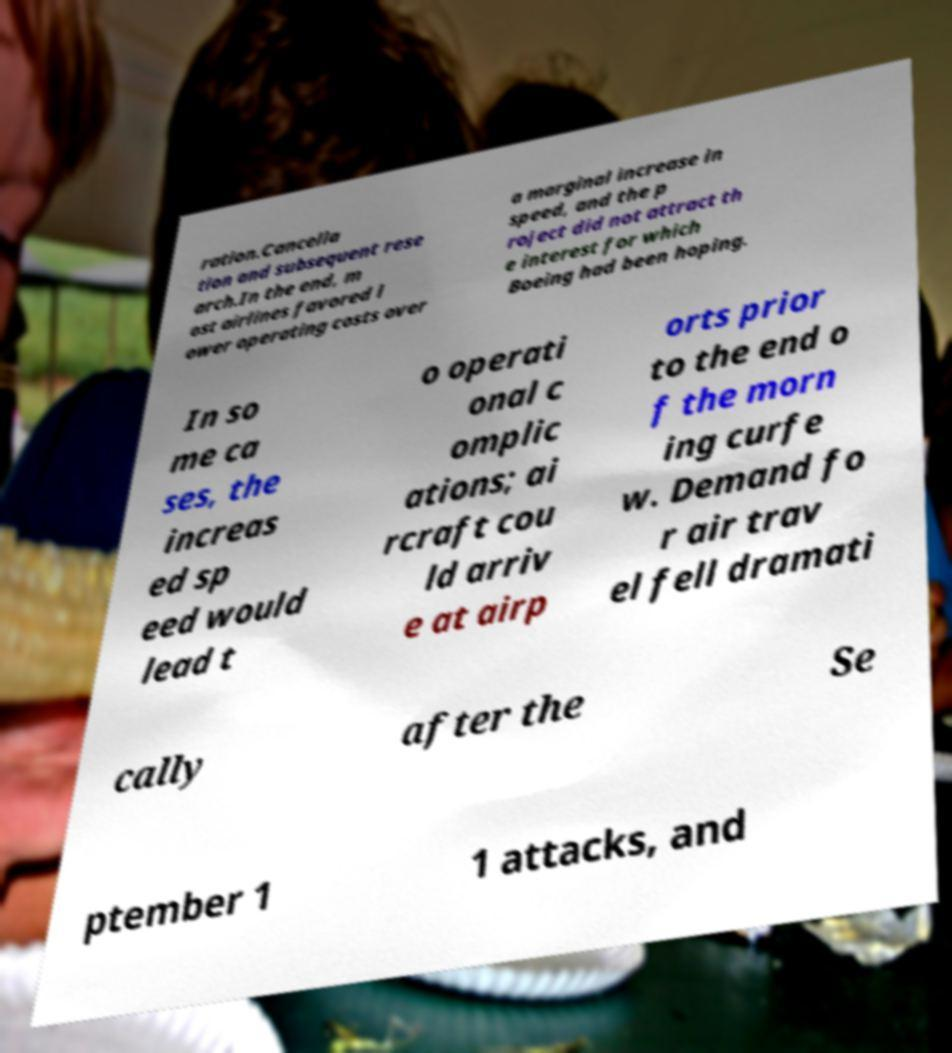I need the written content from this picture converted into text. Can you do that? ration.Cancella tion and subsequent rese arch.In the end, m ost airlines favored l ower operating costs over a marginal increase in speed, and the p roject did not attract th e interest for which Boeing had been hoping. In so me ca ses, the increas ed sp eed would lead t o operati onal c omplic ations; ai rcraft cou ld arriv e at airp orts prior to the end o f the morn ing curfe w. Demand fo r air trav el fell dramati cally after the Se ptember 1 1 attacks, and 